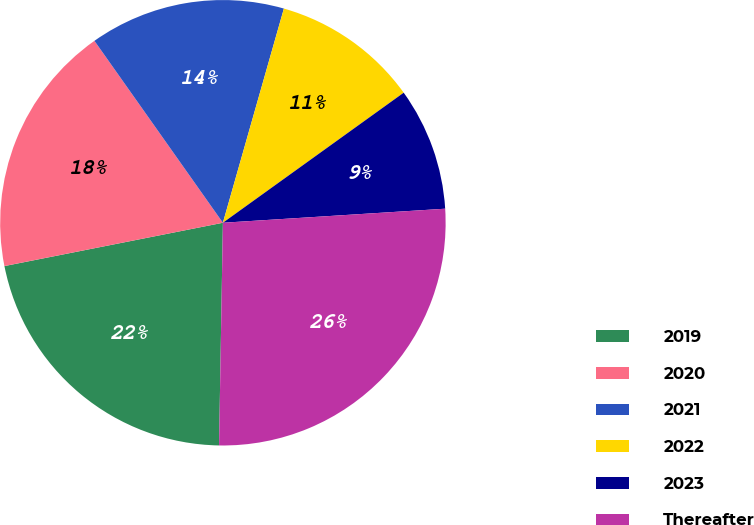Convert chart to OTSL. <chart><loc_0><loc_0><loc_500><loc_500><pie_chart><fcel>2019<fcel>2020<fcel>2021<fcel>2022<fcel>2023<fcel>Thereafter<nl><fcel>21.61%<fcel>18.33%<fcel>14.2%<fcel>10.66%<fcel>8.92%<fcel>26.28%<nl></chart> 